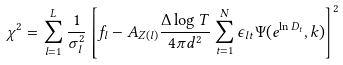<formula> <loc_0><loc_0><loc_500><loc_500>\chi ^ { 2 } = \sum _ { l = 1 } ^ { L } \frac { 1 } { \sigma _ { l } ^ { 2 } } \left [ f _ { l } - A _ { Z ( l ) } \frac { \Delta \log T } { 4 \pi d ^ { 2 } } \sum _ { t = 1 } ^ { N } { \epsilon _ { l t } \Psi ( e ^ { \ln D _ { t } } , k ) } \right ] ^ { 2 }</formula> 